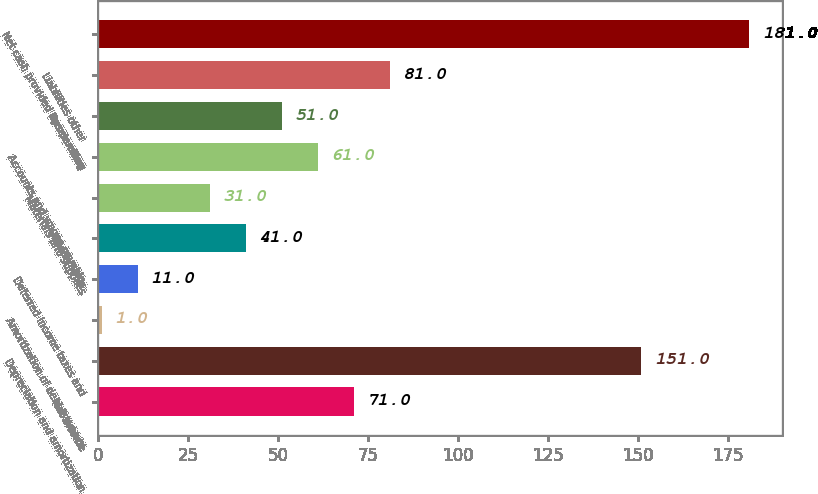<chart> <loc_0><loc_0><loc_500><loc_500><bar_chart><fcel>Net income<fcel>Depreciation and amortization<fcel>Amortization of debt issuance<fcel>Deferred income taxes and<fcel>Receivables<fcel>Materials and supplies<fcel>Accounts and wages payable<fcel>Assets other<fcel>Liabilities other<fcel>Net cash provided by operating<nl><fcel>71<fcel>151<fcel>1<fcel>11<fcel>41<fcel>31<fcel>61<fcel>51<fcel>81<fcel>181<nl></chart> 